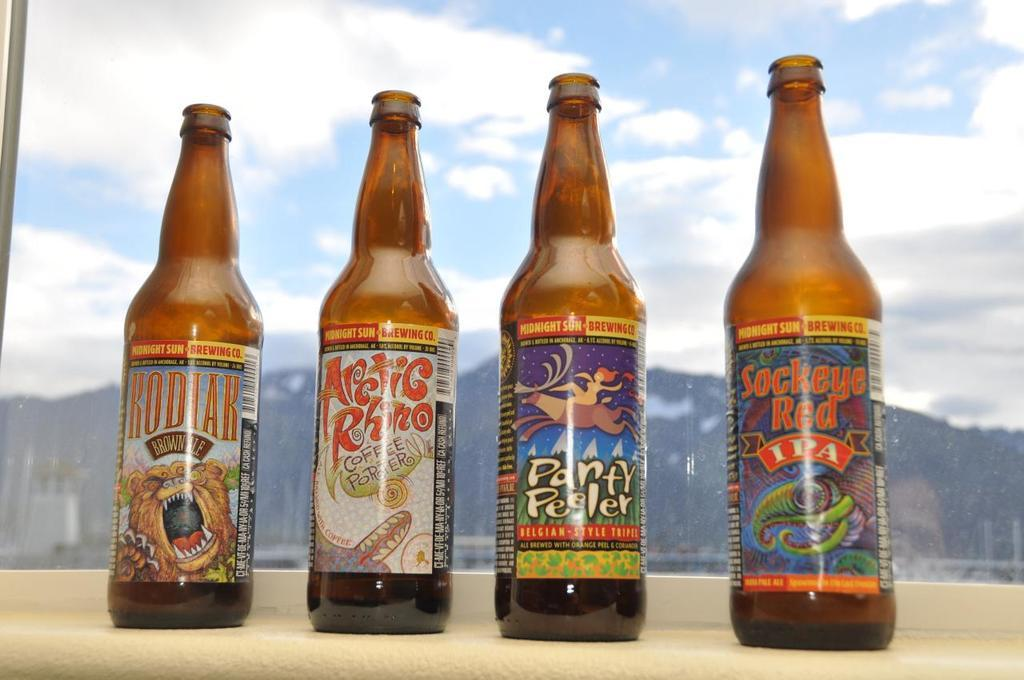How many glass bottles are visible in the image? There are four glass bottles in the image. How many ladybugs are crawling on the glass bottles in the image? There are no ladybugs present in the image; it only features four glass bottles. 